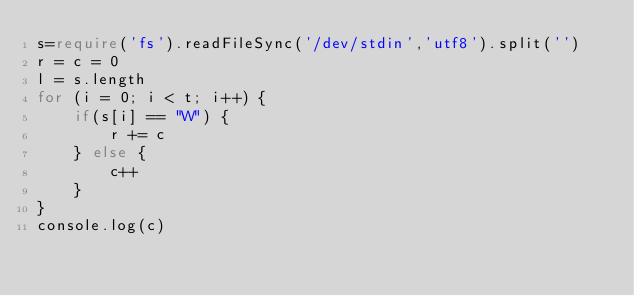<code> <loc_0><loc_0><loc_500><loc_500><_TypeScript_>s=require('fs').readFileSync('/dev/stdin','utf8').split('')
r = c = 0
l = s.length
for (i = 0; i < t; i++) {
	if(s[i] == "W") {
		r += c
	} else {
		c++
	}
}
console.log(c)
</code> 